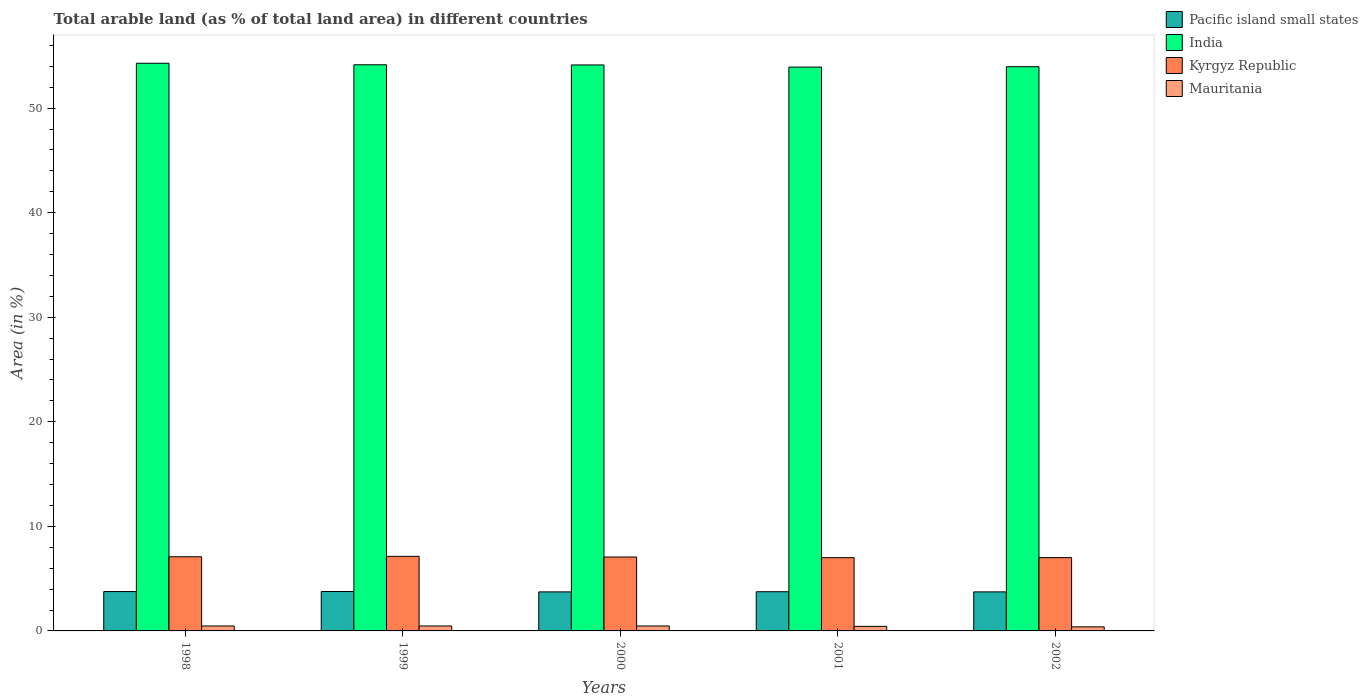How many different coloured bars are there?
Your answer should be compact. 4. How many groups of bars are there?
Offer a terse response. 5. How many bars are there on the 5th tick from the left?
Offer a very short reply. 4. In how many cases, is the number of bars for a given year not equal to the number of legend labels?
Your answer should be very brief. 0. What is the percentage of arable land in India in 1998?
Offer a terse response. 54.29. Across all years, what is the maximum percentage of arable land in Mauritania?
Your answer should be compact. 0.47. Across all years, what is the minimum percentage of arable land in Mauritania?
Provide a short and direct response. 0.39. In which year was the percentage of arable land in Pacific island small states maximum?
Ensure brevity in your answer.  1999. What is the total percentage of arable land in Mauritania in the graph?
Provide a short and direct response. 2.25. What is the difference between the percentage of arable land in India in 2000 and that in 2001?
Offer a very short reply. 0.2. What is the difference between the percentage of arable land in Mauritania in 2000 and the percentage of arable land in Kyrgyz Republic in 2002?
Provide a succinct answer. -6.54. What is the average percentage of arable land in Pacific island small states per year?
Your answer should be compact. 3.75. In the year 2002, what is the difference between the percentage of arable land in Pacific island small states and percentage of arable land in Kyrgyz Republic?
Your answer should be compact. -3.28. What is the ratio of the percentage of arable land in Pacific island small states in 2000 to that in 2001?
Your answer should be compact. 1. Is the difference between the percentage of arable land in Pacific island small states in 1999 and 2000 greater than the difference between the percentage of arable land in Kyrgyz Republic in 1999 and 2000?
Your answer should be very brief. No. What is the difference between the highest and the second highest percentage of arable land in Mauritania?
Provide a succinct answer. 0. What is the difference between the highest and the lowest percentage of arable land in Pacific island small states?
Keep it short and to the point. 0.04. Is the sum of the percentage of arable land in Pacific island small states in 2000 and 2002 greater than the maximum percentage of arable land in Mauritania across all years?
Your answer should be very brief. Yes. Is it the case that in every year, the sum of the percentage of arable land in Mauritania and percentage of arable land in India is greater than the sum of percentage of arable land in Pacific island small states and percentage of arable land in Kyrgyz Republic?
Ensure brevity in your answer.  Yes. What does the 3rd bar from the left in 2002 represents?
Offer a very short reply. Kyrgyz Republic. How many bars are there?
Your response must be concise. 20. Are all the bars in the graph horizontal?
Ensure brevity in your answer.  No. How many years are there in the graph?
Your answer should be compact. 5. What is the difference between two consecutive major ticks on the Y-axis?
Offer a terse response. 10. Are the values on the major ticks of Y-axis written in scientific E-notation?
Offer a very short reply. No. Does the graph contain grids?
Give a very brief answer. No. Where does the legend appear in the graph?
Give a very brief answer. Top right. How many legend labels are there?
Your response must be concise. 4. How are the legend labels stacked?
Offer a very short reply. Vertical. What is the title of the graph?
Keep it short and to the point. Total arable land (as % of total land area) in different countries. What is the label or title of the X-axis?
Provide a succinct answer. Years. What is the label or title of the Y-axis?
Keep it short and to the point. Area (in %). What is the Area (in %) of Pacific island small states in 1998?
Provide a succinct answer. 3.76. What is the Area (in %) of India in 1998?
Your answer should be compact. 54.29. What is the Area (in %) in Kyrgyz Republic in 1998?
Give a very brief answer. 7.09. What is the Area (in %) in Mauritania in 1998?
Offer a terse response. 0.47. What is the Area (in %) in Pacific island small states in 1999?
Your response must be concise. 3.77. What is the Area (in %) of India in 1999?
Your answer should be very brief. 54.14. What is the Area (in %) of Kyrgyz Republic in 1999?
Offer a terse response. 7.13. What is the Area (in %) of Mauritania in 1999?
Your response must be concise. 0.47. What is the Area (in %) of Pacific island small states in 2000?
Ensure brevity in your answer.  3.73. What is the Area (in %) of India in 2000?
Your response must be concise. 54.13. What is the Area (in %) of Kyrgyz Republic in 2000?
Your response must be concise. 7.07. What is the Area (in %) of Mauritania in 2000?
Offer a very short reply. 0.47. What is the Area (in %) in Pacific island small states in 2001?
Keep it short and to the point. 3.75. What is the Area (in %) in India in 2001?
Provide a succinct answer. 53.92. What is the Area (in %) of Kyrgyz Republic in 2001?
Keep it short and to the point. 7.01. What is the Area (in %) of Mauritania in 2001?
Provide a short and direct response. 0.44. What is the Area (in %) in Pacific island small states in 2002?
Provide a succinct answer. 3.73. What is the Area (in %) of India in 2002?
Offer a very short reply. 53.96. What is the Area (in %) of Kyrgyz Republic in 2002?
Make the answer very short. 7.01. What is the Area (in %) of Mauritania in 2002?
Offer a terse response. 0.39. Across all years, what is the maximum Area (in %) in Pacific island small states?
Make the answer very short. 3.77. Across all years, what is the maximum Area (in %) in India?
Make the answer very short. 54.29. Across all years, what is the maximum Area (in %) of Kyrgyz Republic?
Give a very brief answer. 7.13. Across all years, what is the maximum Area (in %) of Mauritania?
Ensure brevity in your answer.  0.47. Across all years, what is the minimum Area (in %) in Pacific island small states?
Your response must be concise. 3.73. Across all years, what is the minimum Area (in %) of India?
Offer a very short reply. 53.92. Across all years, what is the minimum Area (in %) in Kyrgyz Republic?
Keep it short and to the point. 7.01. Across all years, what is the minimum Area (in %) of Mauritania?
Your answer should be very brief. 0.39. What is the total Area (in %) of Pacific island small states in the graph?
Provide a succinct answer. 18.75. What is the total Area (in %) of India in the graph?
Offer a terse response. 270.44. What is the total Area (in %) in Kyrgyz Republic in the graph?
Keep it short and to the point. 35.31. What is the total Area (in %) in Mauritania in the graph?
Keep it short and to the point. 2.25. What is the difference between the Area (in %) in Pacific island small states in 1998 and that in 1999?
Provide a short and direct response. -0. What is the difference between the Area (in %) in India in 1998 and that in 1999?
Make the answer very short. 0.15. What is the difference between the Area (in %) in Kyrgyz Republic in 1998 and that in 1999?
Your answer should be compact. -0.04. What is the difference between the Area (in %) in Pacific island small states in 1998 and that in 2000?
Ensure brevity in your answer.  0.03. What is the difference between the Area (in %) in India in 1998 and that in 2000?
Give a very brief answer. 0.16. What is the difference between the Area (in %) of Kyrgyz Republic in 1998 and that in 2000?
Make the answer very short. 0.02. What is the difference between the Area (in %) in Pacific island small states in 1998 and that in 2001?
Provide a succinct answer. 0.02. What is the difference between the Area (in %) of India in 1998 and that in 2001?
Offer a very short reply. 0.36. What is the difference between the Area (in %) of Kyrgyz Republic in 1998 and that in 2001?
Provide a short and direct response. 0.08. What is the difference between the Area (in %) of Mauritania in 1998 and that in 2001?
Give a very brief answer. 0.04. What is the difference between the Area (in %) in Pacific island small states in 1998 and that in 2002?
Keep it short and to the point. 0.03. What is the difference between the Area (in %) of India in 1998 and that in 2002?
Your answer should be compact. 0.33. What is the difference between the Area (in %) in Kyrgyz Republic in 1998 and that in 2002?
Your answer should be compact. 0.08. What is the difference between the Area (in %) in Mauritania in 1998 and that in 2002?
Make the answer very short. 0.09. What is the difference between the Area (in %) of Pacific island small states in 1999 and that in 2000?
Your response must be concise. 0.04. What is the difference between the Area (in %) of India in 1999 and that in 2000?
Your answer should be very brief. 0.02. What is the difference between the Area (in %) of Kyrgyz Republic in 1999 and that in 2000?
Your answer should be very brief. 0.06. What is the difference between the Area (in %) in Mauritania in 1999 and that in 2000?
Make the answer very short. 0. What is the difference between the Area (in %) in Pacific island small states in 1999 and that in 2001?
Make the answer very short. 0.02. What is the difference between the Area (in %) of India in 1999 and that in 2001?
Your answer should be compact. 0.22. What is the difference between the Area (in %) in Kyrgyz Republic in 1999 and that in 2001?
Offer a very short reply. 0.13. What is the difference between the Area (in %) in Mauritania in 1999 and that in 2001?
Ensure brevity in your answer.  0.04. What is the difference between the Area (in %) of Pacific island small states in 1999 and that in 2002?
Give a very brief answer. 0.04. What is the difference between the Area (in %) of India in 1999 and that in 2002?
Provide a short and direct response. 0.18. What is the difference between the Area (in %) of Kyrgyz Republic in 1999 and that in 2002?
Offer a terse response. 0.12. What is the difference between the Area (in %) of Mauritania in 1999 and that in 2002?
Provide a short and direct response. 0.09. What is the difference between the Area (in %) of Pacific island small states in 2000 and that in 2001?
Ensure brevity in your answer.  -0.02. What is the difference between the Area (in %) in India in 2000 and that in 2001?
Your answer should be compact. 0.2. What is the difference between the Area (in %) of Kyrgyz Republic in 2000 and that in 2001?
Offer a very short reply. 0.06. What is the difference between the Area (in %) in Mauritania in 2000 and that in 2001?
Keep it short and to the point. 0.04. What is the difference between the Area (in %) of Pacific island small states in 2000 and that in 2002?
Provide a succinct answer. 0. What is the difference between the Area (in %) of India in 2000 and that in 2002?
Keep it short and to the point. 0.17. What is the difference between the Area (in %) of Kyrgyz Republic in 2000 and that in 2002?
Your answer should be very brief. 0.06. What is the difference between the Area (in %) in Mauritania in 2000 and that in 2002?
Your answer should be very brief. 0.09. What is the difference between the Area (in %) in Pacific island small states in 2001 and that in 2002?
Offer a very short reply. 0.02. What is the difference between the Area (in %) in India in 2001 and that in 2002?
Give a very brief answer. -0.04. What is the difference between the Area (in %) of Kyrgyz Republic in 2001 and that in 2002?
Provide a short and direct response. -0.01. What is the difference between the Area (in %) in Mauritania in 2001 and that in 2002?
Provide a short and direct response. 0.05. What is the difference between the Area (in %) in Pacific island small states in 1998 and the Area (in %) in India in 1999?
Provide a succinct answer. -50.38. What is the difference between the Area (in %) in Pacific island small states in 1998 and the Area (in %) in Kyrgyz Republic in 1999?
Keep it short and to the point. -3.37. What is the difference between the Area (in %) in Pacific island small states in 1998 and the Area (in %) in Mauritania in 1999?
Keep it short and to the point. 3.29. What is the difference between the Area (in %) of India in 1998 and the Area (in %) of Kyrgyz Republic in 1999?
Provide a short and direct response. 47.16. What is the difference between the Area (in %) in India in 1998 and the Area (in %) in Mauritania in 1999?
Your response must be concise. 53.81. What is the difference between the Area (in %) in Kyrgyz Republic in 1998 and the Area (in %) in Mauritania in 1999?
Give a very brief answer. 6.62. What is the difference between the Area (in %) in Pacific island small states in 1998 and the Area (in %) in India in 2000?
Your response must be concise. -50.36. What is the difference between the Area (in %) of Pacific island small states in 1998 and the Area (in %) of Kyrgyz Republic in 2000?
Ensure brevity in your answer.  -3.31. What is the difference between the Area (in %) in Pacific island small states in 1998 and the Area (in %) in Mauritania in 2000?
Provide a short and direct response. 3.29. What is the difference between the Area (in %) of India in 1998 and the Area (in %) of Kyrgyz Republic in 2000?
Give a very brief answer. 47.22. What is the difference between the Area (in %) in India in 1998 and the Area (in %) in Mauritania in 2000?
Your answer should be very brief. 53.81. What is the difference between the Area (in %) in Kyrgyz Republic in 1998 and the Area (in %) in Mauritania in 2000?
Your answer should be compact. 6.62. What is the difference between the Area (in %) of Pacific island small states in 1998 and the Area (in %) of India in 2001?
Provide a succinct answer. -50.16. What is the difference between the Area (in %) in Pacific island small states in 1998 and the Area (in %) in Kyrgyz Republic in 2001?
Provide a succinct answer. -3.24. What is the difference between the Area (in %) in Pacific island small states in 1998 and the Area (in %) in Mauritania in 2001?
Offer a terse response. 3.33. What is the difference between the Area (in %) in India in 1998 and the Area (in %) in Kyrgyz Republic in 2001?
Offer a terse response. 47.28. What is the difference between the Area (in %) in India in 1998 and the Area (in %) in Mauritania in 2001?
Make the answer very short. 53.85. What is the difference between the Area (in %) in Kyrgyz Republic in 1998 and the Area (in %) in Mauritania in 2001?
Make the answer very short. 6.65. What is the difference between the Area (in %) in Pacific island small states in 1998 and the Area (in %) in India in 2002?
Give a very brief answer. -50.19. What is the difference between the Area (in %) of Pacific island small states in 1998 and the Area (in %) of Kyrgyz Republic in 2002?
Provide a succinct answer. -3.25. What is the difference between the Area (in %) of Pacific island small states in 1998 and the Area (in %) of Mauritania in 2002?
Provide a short and direct response. 3.38. What is the difference between the Area (in %) of India in 1998 and the Area (in %) of Kyrgyz Republic in 2002?
Keep it short and to the point. 47.28. What is the difference between the Area (in %) in India in 1998 and the Area (in %) in Mauritania in 2002?
Ensure brevity in your answer.  53.9. What is the difference between the Area (in %) in Kyrgyz Republic in 1998 and the Area (in %) in Mauritania in 2002?
Give a very brief answer. 6.7. What is the difference between the Area (in %) of Pacific island small states in 1999 and the Area (in %) of India in 2000?
Make the answer very short. -50.36. What is the difference between the Area (in %) in Pacific island small states in 1999 and the Area (in %) in Kyrgyz Republic in 2000?
Provide a short and direct response. -3.3. What is the difference between the Area (in %) in Pacific island small states in 1999 and the Area (in %) in Mauritania in 2000?
Make the answer very short. 3.3. What is the difference between the Area (in %) of India in 1999 and the Area (in %) of Kyrgyz Republic in 2000?
Offer a very short reply. 47.07. What is the difference between the Area (in %) in India in 1999 and the Area (in %) in Mauritania in 2000?
Keep it short and to the point. 53.67. What is the difference between the Area (in %) of Kyrgyz Republic in 1999 and the Area (in %) of Mauritania in 2000?
Your answer should be very brief. 6.66. What is the difference between the Area (in %) in Pacific island small states in 1999 and the Area (in %) in India in 2001?
Your answer should be compact. -50.15. What is the difference between the Area (in %) in Pacific island small states in 1999 and the Area (in %) in Kyrgyz Republic in 2001?
Your answer should be compact. -3.24. What is the difference between the Area (in %) in Pacific island small states in 1999 and the Area (in %) in Mauritania in 2001?
Keep it short and to the point. 3.33. What is the difference between the Area (in %) of India in 1999 and the Area (in %) of Kyrgyz Republic in 2001?
Your response must be concise. 47.13. What is the difference between the Area (in %) in India in 1999 and the Area (in %) in Mauritania in 2001?
Offer a very short reply. 53.71. What is the difference between the Area (in %) in Kyrgyz Republic in 1999 and the Area (in %) in Mauritania in 2001?
Your response must be concise. 6.7. What is the difference between the Area (in %) in Pacific island small states in 1999 and the Area (in %) in India in 2002?
Offer a terse response. -50.19. What is the difference between the Area (in %) of Pacific island small states in 1999 and the Area (in %) of Kyrgyz Republic in 2002?
Your answer should be compact. -3.24. What is the difference between the Area (in %) in Pacific island small states in 1999 and the Area (in %) in Mauritania in 2002?
Provide a short and direct response. 3.38. What is the difference between the Area (in %) in India in 1999 and the Area (in %) in Kyrgyz Republic in 2002?
Your answer should be compact. 47.13. What is the difference between the Area (in %) of India in 1999 and the Area (in %) of Mauritania in 2002?
Your answer should be compact. 53.75. What is the difference between the Area (in %) in Kyrgyz Republic in 1999 and the Area (in %) in Mauritania in 2002?
Offer a terse response. 6.74. What is the difference between the Area (in %) in Pacific island small states in 2000 and the Area (in %) in India in 2001?
Ensure brevity in your answer.  -50.19. What is the difference between the Area (in %) of Pacific island small states in 2000 and the Area (in %) of Kyrgyz Republic in 2001?
Your answer should be compact. -3.27. What is the difference between the Area (in %) of Pacific island small states in 2000 and the Area (in %) of Mauritania in 2001?
Your answer should be compact. 3.3. What is the difference between the Area (in %) of India in 2000 and the Area (in %) of Kyrgyz Republic in 2001?
Offer a terse response. 47.12. What is the difference between the Area (in %) in India in 2000 and the Area (in %) in Mauritania in 2001?
Provide a succinct answer. 53.69. What is the difference between the Area (in %) in Kyrgyz Republic in 2000 and the Area (in %) in Mauritania in 2001?
Provide a short and direct response. 6.63. What is the difference between the Area (in %) in Pacific island small states in 2000 and the Area (in %) in India in 2002?
Provide a short and direct response. -50.23. What is the difference between the Area (in %) of Pacific island small states in 2000 and the Area (in %) of Kyrgyz Republic in 2002?
Provide a short and direct response. -3.28. What is the difference between the Area (in %) of Pacific island small states in 2000 and the Area (in %) of Mauritania in 2002?
Your response must be concise. 3.35. What is the difference between the Area (in %) of India in 2000 and the Area (in %) of Kyrgyz Republic in 2002?
Make the answer very short. 47.11. What is the difference between the Area (in %) in India in 2000 and the Area (in %) in Mauritania in 2002?
Provide a succinct answer. 53.74. What is the difference between the Area (in %) of Kyrgyz Republic in 2000 and the Area (in %) of Mauritania in 2002?
Give a very brief answer. 6.68. What is the difference between the Area (in %) of Pacific island small states in 2001 and the Area (in %) of India in 2002?
Your response must be concise. -50.21. What is the difference between the Area (in %) of Pacific island small states in 2001 and the Area (in %) of Kyrgyz Republic in 2002?
Your response must be concise. -3.26. What is the difference between the Area (in %) of Pacific island small states in 2001 and the Area (in %) of Mauritania in 2002?
Offer a very short reply. 3.36. What is the difference between the Area (in %) of India in 2001 and the Area (in %) of Kyrgyz Republic in 2002?
Ensure brevity in your answer.  46.91. What is the difference between the Area (in %) of India in 2001 and the Area (in %) of Mauritania in 2002?
Offer a terse response. 53.54. What is the difference between the Area (in %) in Kyrgyz Republic in 2001 and the Area (in %) in Mauritania in 2002?
Provide a succinct answer. 6.62. What is the average Area (in %) of Pacific island small states per year?
Offer a terse response. 3.75. What is the average Area (in %) in India per year?
Keep it short and to the point. 54.09. What is the average Area (in %) in Kyrgyz Republic per year?
Offer a terse response. 7.06. What is the average Area (in %) in Mauritania per year?
Provide a succinct answer. 0.45. In the year 1998, what is the difference between the Area (in %) in Pacific island small states and Area (in %) in India?
Your answer should be compact. -50.52. In the year 1998, what is the difference between the Area (in %) of Pacific island small states and Area (in %) of Kyrgyz Republic?
Provide a short and direct response. -3.33. In the year 1998, what is the difference between the Area (in %) of Pacific island small states and Area (in %) of Mauritania?
Make the answer very short. 3.29. In the year 1998, what is the difference between the Area (in %) of India and Area (in %) of Kyrgyz Republic?
Your answer should be compact. 47.2. In the year 1998, what is the difference between the Area (in %) in India and Area (in %) in Mauritania?
Provide a short and direct response. 53.81. In the year 1998, what is the difference between the Area (in %) in Kyrgyz Republic and Area (in %) in Mauritania?
Offer a very short reply. 6.62. In the year 1999, what is the difference between the Area (in %) in Pacific island small states and Area (in %) in India?
Your response must be concise. -50.37. In the year 1999, what is the difference between the Area (in %) of Pacific island small states and Area (in %) of Kyrgyz Republic?
Your answer should be very brief. -3.36. In the year 1999, what is the difference between the Area (in %) of Pacific island small states and Area (in %) of Mauritania?
Offer a very short reply. 3.3. In the year 1999, what is the difference between the Area (in %) of India and Area (in %) of Kyrgyz Republic?
Provide a short and direct response. 47.01. In the year 1999, what is the difference between the Area (in %) of India and Area (in %) of Mauritania?
Offer a very short reply. 53.67. In the year 1999, what is the difference between the Area (in %) in Kyrgyz Republic and Area (in %) in Mauritania?
Provide a succinct answer. 6.66. In the year 2000, what is the difference between the Area (in %) of Pacific island small states and Area (in %) of India?
Offer a very short reply. -50.39. In the year 2000, what is the difference between the Area (in %) of Pacific island small states and Area (in %) of Kyrgyz Republic?
Keep it short and to the point. -3.34. In the year 2000, what is the difference between the Area (in %) of Pacific island small states and Area (in %) of Mauritania?
Your answer should be compact. 3.26. In the year 2000, what is the difference between the Area (in %) in India and Area (in %) in Kyrgyz Republic?
Your answer should be very brief. 47.06. In the year 2000, what is the difference between the Area (in %) in India and Area (in %) in Mauritania?
Provide a succinct answer. 53.65. In the year 2000, what is the difference between the Area (in %) in Kyrgyz Republic and Area (in %) in Mauritania?
Give a very brief answer. 6.6. In the year 2001, what is the difference between the Area (in %) of Pacific island small states and Area (in %) of India?
Your answer should be very brief. -50.17. In the year 2001, what is the difference between the Area (in %) of Pacific island small states and Area (in %) of Kyrgyz Republic?
Your response must be concise. -3.26. In the year 2001, what is the difference between the Area (in %) of Pacific island small states and Area (in %) of Mauritania?
Give a very brief answer. 3.31. In the year 2001, what is the difference between the Area (in %) in India and Area (in %) in Kyrgyz Republic?
Provide a succinct answer. 46.92. In the year 2001, what is the difference between the Area (in %) of India and Area (in %) of Mauritania?
Provide a succinct answer. 53.49. In the year 2001, what is the difference between the Area (in %) of Kyrgyz Republic and Area (in %) of Mauritania?
Give a very brief answer. 6.57. In the year 2002, what is the difference between the Area (in %) of Pacific island small states and Area (in %) of India?
Offer a terse response. -50.23. In the year 2002, what is the difference between the Area (in %) in Pacific island small states and Area (in %) in Kyrgyz Republic?
Provide a short and direct response. -3.28. In the year 2002, what is the difference between the Area (in %) in Pacific island small states and Area (in %) in Mauritania?
Offer a terse response. 3.35. In the year 2002, what is the difference between the Area (in %) of India and Area (in %) of Kyrgyz Republic?
Your answer should be compact. 46.95. In the year 2002, what is the difference between the Area (in %) of India and Area (in %) of Mauritania?
Your answer should be compact. 53.57. In the year 2002, what is the difference between the Area (in %) of Kyrgyz Republic and Area (in %) of Mauritania?
Your answer should be very brief. 6.62. What is the ratio of the Area (in %) of Pacific island small states in 1998 to that in 1999?
Your response must be concise. 1. What is the ratio of the Area (in %) in Pacific island small states in 1998 to that in 2000?
Your answer should be very brief. 1.01. What is the ratio of the Area (in %) of Kyrgyz Republic in 1998 to that in 2000?
Your answer should be compact. 1. What is the ratio of the Area (in %) of Pacific island small states in 1998 to that in 2001?
Offer a terse response. 1. What is the ratio of the Area (in %) in India in 1998 to that in 2001?
Ensure brevity in your answer.  1.01. What is the ratio of the Area (in %) of Kyrgyz Republic in 1998 to that in 2001?
Make the answer very short. 1.01. What is the ratio of the Area (in %) in Mauritania in 1998 to that in 2001?
Your answer should be very brief. 1.08. What is the ratio of the Area (in %) in Pacific island small states in 1998 to that in 2002?
Provide a succinct answer. 1.01. What is the ratio of the Area (in %) of Kyrgyz Republic in 1998 to that in 2002?
Offer a terse response. 1.01. What is the ratio of the Area (in %) in Mauritania in 1998 to that in 2002?
Give a very brief answer. 1.22. What is the ratio of the Area (in %) in Pacific island small states in 1999 to that in 2000?
Your answer should be very brief. 1.01. What is the ratio of the Area (in %) in Kyrgyz Republic in 1999 to that in 2000?
Your answer should be very brief. 1.01. What is the ratio of the Area (in %) of Pacific island small states in 1999 to that in 2001?
Your answer should be very brief. 1.01. What is the ratio of the Area (in %) of India in 1999 to that in 2001?
Make the answer very short. 1. What is the ratio of the Area (in %) of Kyrgyz Republic in 1999 to that in 2001?
Give a very brief answer. 1.02. What is the ratio of the Area (in %) in Mauritania in 1999 to that in 2001?
Make the answer very short. 1.08. What is the ratio of the Area (in %) of Pacific island small states in 1999 to that in 2002?
Keep it short and to the point. 1.01. What is the ratio of the Area (in %) of Kyrgyz Republic in 1999 to that in 2002?
Offer a very short reply. 1.02. What is the ratio of the Area (in %) in Mauritania in 1999 to that in 2002?
Make the answer very short. 1.22. What is the ratio of the Area (in %) of India in 2000 to that in 2001?
Ensure brevity in your answer.  1. What is the ratio of the Area (in %) of Kyrgyz Republic in 2000 to that in 2001?
Your answer should be compact. 1.01. What is the ratio of the Area (in %) in Mauritania in 2000 to that in 2001?
Your answer should be compact. 1.08. What is the ratio of the Area (in %) in Pacific island small states in 2000 to that in 2002?
Ensure brevity in your answer.  1. What is the ratio of the Area (in %) of Kyrgyz Republic in 2000 to that in 2002?
Make the answer very short. 1.01. What is the ratio of the Area (in %) of Mauritania in 2000 to that in 2002?
Provide a succinct answer. 1.22. What is the ratio of the Area (in %) of Mauritania in 2001 to that in 2002?
Your answer should be very brief. 1.12. What is the difference between the highest and the second highest Area (in %) of Pacific island small states?
Keep it short and to the point. 0. What is the difference between the highest and the second highest Area (in %) of India?
Offer a terse response. 0.15. What is the difference between the highest and the second highest Area (in %) of Kyrgyz Republic?
Give a very brief answer. 0.04. What is the difference between the highest and the lowest Area (in %) of Pacific island small states?
Keep it short and to the point. 0.04. What is the difference between the highest and the lowest Area (in %) in India?
Your answer should be compact. 0.36. What is the difference between the highest and the lowest Area (in %) of Kyrgyz Republic?
Your answer should be compact. 0.13. What is the difference between the highest and the lowest Area (in %) of Mauritania?
Keep it short and to the point. 0.09. 